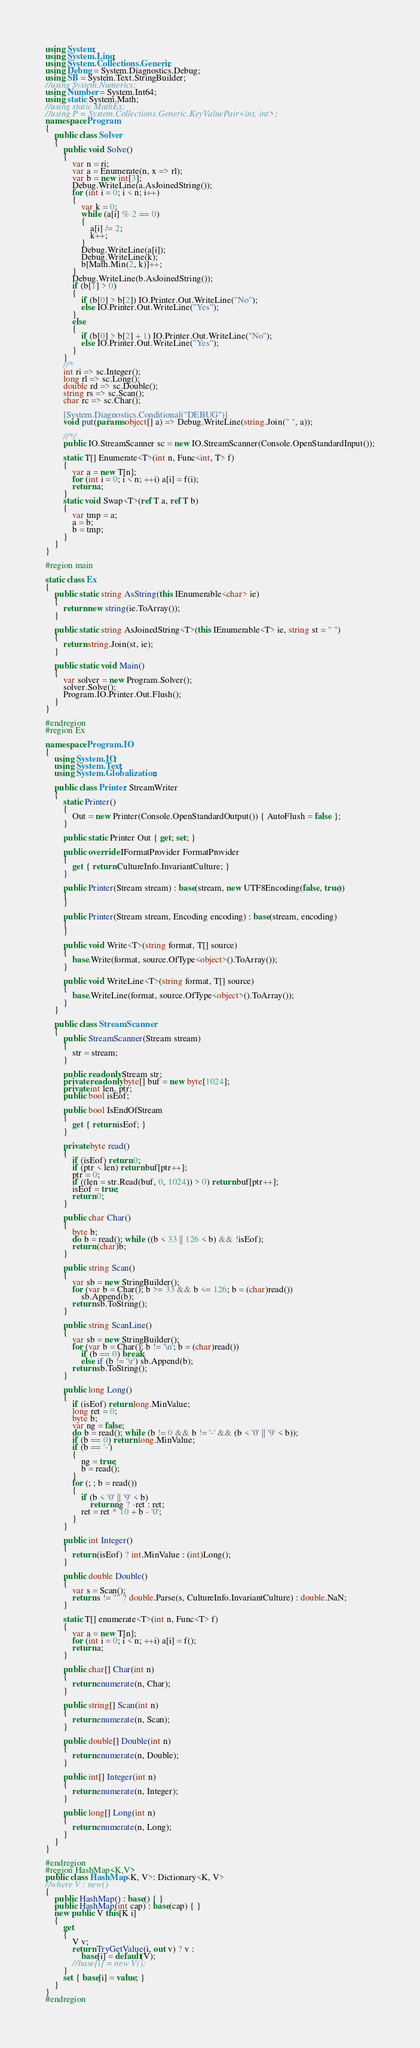Convert code to text. <code><loc_0><loc_0><loc_500><loc_500><_C#_>using System;
using System.Linq;
using System.Collections.Generic;
using Debug = System.Diagnostics.Debug;
using SB = System.Text.StringBuilder;
//using System.Numerics;
using Number = System.Int64;
using static System.Math;
//using static MathEx;
//using P = System.Collections.Generic.KeyValuePair<int, int>;
namespace Program
{
    public class Solver
    {
        public void Solve()
        {
            var n = ri;
            var a = Enumerate(n, x => rl);
            var b = new int[3];
            Debug.WriteLine(a.AsJoinedString());
            for (int i = 0; i < n; i++)
            {
                var k = 0;
                while (a[i] % 2 == 0)
                {
                    a[i] /= 2;
                    k++;
                }
                Debug.WriteLine(a[i]);
                Debug.WriteLine(k);
                b[Math.Min(2, k)]++;
            }
            Debug.WriteLine(b.AsJoinedString());
            if (b[1] > 0)
            {
                if (b[0] > b[2]) IO.Printer.Out.WriteLine("No");
                else IO.Printer.Out.WriteLine("Yes");
            }
            else
            {
                if (b[0] > b[2] + 1) IO.Printer.Out.WriteLine("No");
                else IO.Printer.Out.WriteLine("Yes");
            }
        }
        //*
        int ri => sc.Integer();
        long rl => sc.Long();
        double rd => sc.Double();
        string rs => sc.Scan();
        char rc => sc.Char();

        [System.Diagnostics.Conditional("DEBUG")]
        void put(params object[] a) => Debug.WriteLine(string.Join(" ", a));

        //*/
        public IO.StreamScanner sc = new IO.StreamScanner(Console.OpenStandardInput());

        static T[] Enumerate<T>(int n, Func<int, T> f)
        {
            var a = new T[n];
            for (int i = 0; i < n; ++i) a[i] = f(i);
            return a;
        }
        static void Swap<T>(ref T a, ref T b)
        {
            var tmp = a;
            a = b;
            b = tmp;
        }
    }
}

#region main

static class Ex
{
    public static string AsString(this IEnumerable<char> ie)
    {
        return new string(ie.ToArray());
    }

    public static string AsJoinedString<T>(this IEnumerable<T> ie, string st = " ")
    {
        return string.Join(st, ie);
    }

    public static void Main()
    {
        var solver = new Program.Solver();
        solver.Solve();
        Program.IO.Printer.Out.Flush();
    }
}

#endregion
#region Ex

namespace Program.IO
{
    using System.IO;
    using System.Text;
    using System.Globalization;

    public class Printer: StreamWriter
    {
        static Printer()
        {
            Out = new Printer(Console.OpenStandardOutput()) { AutoFlush = false };
        }

        public static Printer Out { get; set; }

        public override IFormatProvider FormatProvider
        {
            get { return CultureInfo.InvariantCulture; }
        }

        public Printer(Stream stream) : base(stream, new UTF8Encoding(false, true))
        {
        }

        public Printer(Stream stream, Encoding encoding) : base(stream, encoding)
        {
        }

        public void Write<T>(string format, T[] source)
        {
            base.Write(format, source.OfType<object>().ToArray());
        }

        public void WriteLine<T>(string format, T[] source)
        {
            base.WriteLine(format, source.OfType<object>().ToArray());
        }
    }

    public class StreamScanner
    {
        public StreamScanner(Stream stream)
        {
            str = stream;
        }

        public readonly Stream str;
        private readonly byte[] buf = new byte[1024];
        private int len, ptr;
        public bool isEof;

        public bool IsEndOfStream
        {
            get { return isEof; }
        }

        private byte read()
        {
            if (isEof) return 0;
            if (ptr < len) return buf[ptr++];
            ptr = 0;
            if ((len = str.Read(buf, 0, 1024)) > 0) return buf[ptr++];
            isEof = true;
            return 0;
        }

        public char Char()
        {
            byte b;
            do b = read(); while ((b < 33 || 126 < b) && !isEof);
            return (char)b;
        }

        public string Scan()
        {
            var sb = new StringBuilder();
            for (var b = Char(); b >= 33 && b <= 126; b = (char)read())
                sb.Append(b);
            return sb.ToString();
        }

        public string ScanLine()
        {
            var sb = new StringBuilder();
            for (var b = Char(); b != '\n'; b = (char)read())
                if (b == 0) break;
                else if (b != '\r') sb.Append(b);
            return sb.ToString();
        }

        public long Long()
        {
            if (isEof) return long.MinValue;
            long ret = 0;
            byte b;
            var ng = false;
            do b = read(); while (b != 0 && b != '-' && (b < '0' || '9' < b));
            if (b == 0) return long.MinValue;
            if (b == '-')
            {
                ng = true;
                b = read();
            }
            for (; ; b = read())
            {
                if (b < '0' || '9' < b)
                    return ng ? -ret : ret;
                ret = ret * 10 + b - '0';
            }
        }

        public int Integer()
        {
            return (isEof) ? int.MinValue : (int)Long();
        }

        public double Double()
        {
            var s = Scan();
            return s != "" ? double.Parse(s, CultureInfo.InvariantCulture) : double.NaN;
        }

        static T[] enumerate<T>(int n, Func<T> f)
        {
            var a = new T[n];
            for (int i = 0; i < n; ++i) a[i] = f();
            return a;
        }

        public char[] Char(int n)
        {
            return enumerate(n, Char);
        }

        public string[] Scan(int n)
        {
            return enumerate(n, Scan);
        }

        public double[] Double(int n)
        {
            return enumerate(n, Double);
        }

        public int[] Integer(int n)
        {
            return enumerate(n, Integer);
        }

        public long[] Long(int n)
        {
            return enumerate(n, Long);
        }
    }
}

#endregion
#region HashMap<K,V>
public class HashMap<K, V>: Dictionary<K, V>
//where V : new()
{
    public HashMap() : base() { }
    public HashMap(int cap) : base(cap) { }
    new public V this[K i]
    {
        get
        {
            V v;
            return TryGetValue(i, out v) ? v :
                base[i] = default(V);
            //base[i] = new V();
        }
        set { base[i] = value; }
    }
}
#endregion</code> 